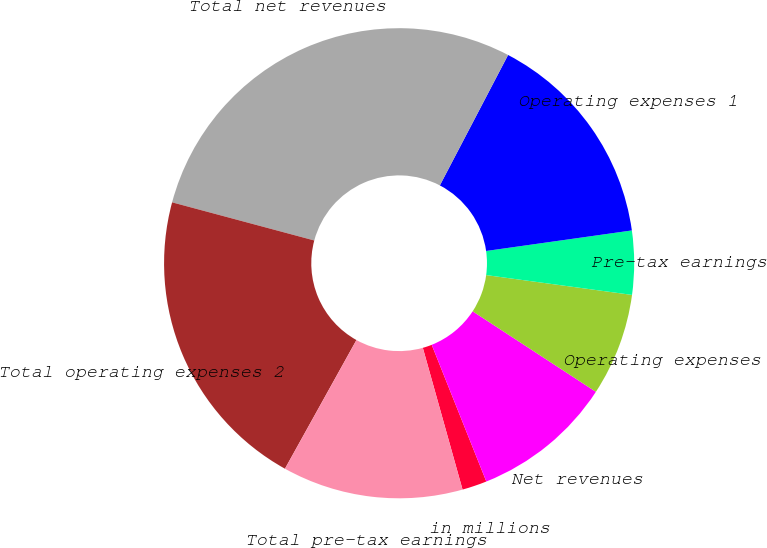Convert chart. <chart><loc_0><loc_0><loc_500><loc_500><pie_chart><fcel>in millions<fcel>Net revenues<fcel>Operating expenses<fcel>Pre-tax earnings<fcel>Operating expenses 1<fcel>Total net revenues<fcel>Total operating expenses 2<fcel>Total pre-tax earnings<nl><fcel>1.7%<fcel>9.74%<fcel>7.06%<fcel>4.38%<fcel>15.1%<fcel>28.5%<fcel>21.1%<fcel>12.42%<nl></chart> 